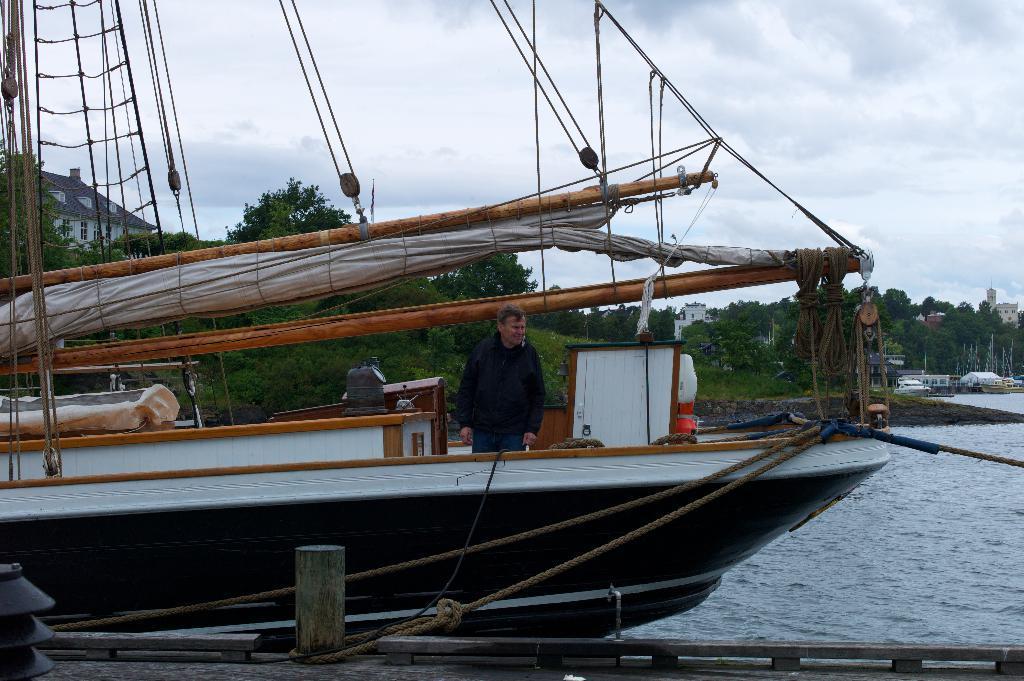Please provide a concise description of this image. In this picture i can see a man is standing on the boat. v In the background I can see trees and water. On the right side I can see buildings and boats. 